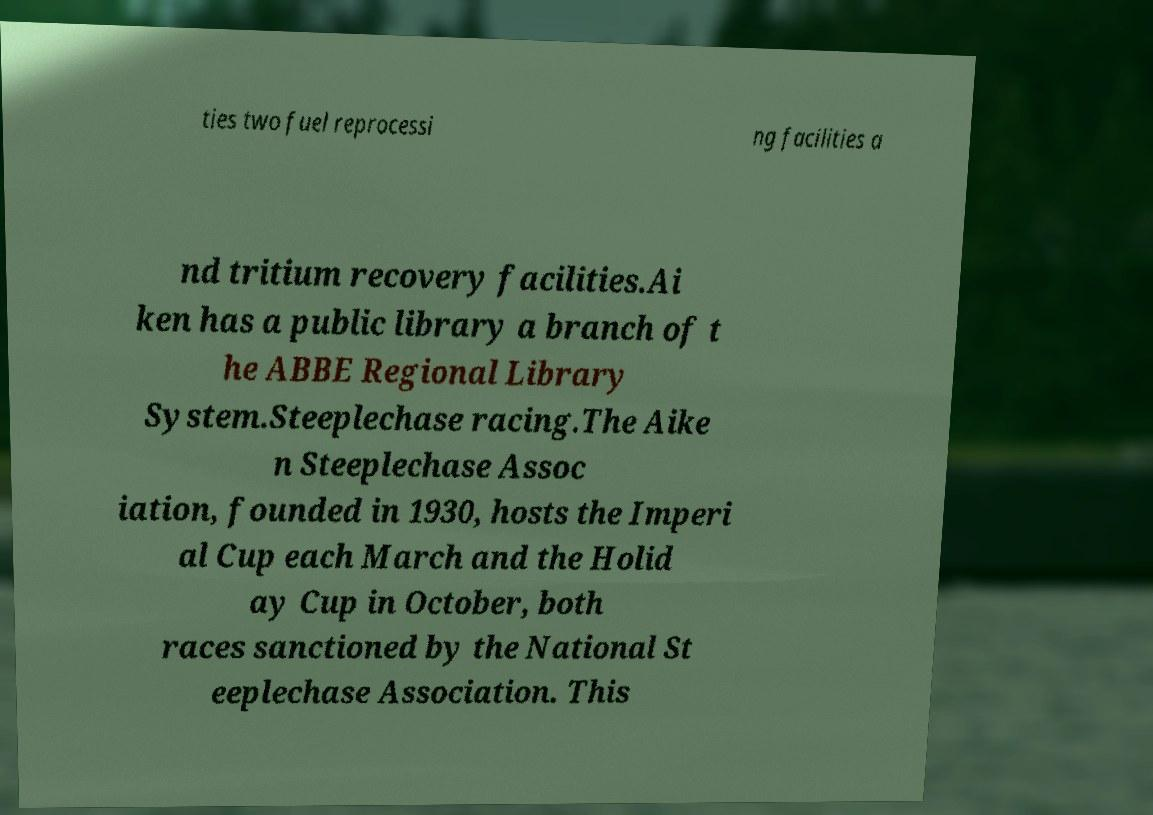For documentation purposes, I need the text within this image transcribed. Could you provide that? ties two fuel reprocessi ng facilities a nd tritium recovery facilities.Ai ken has a public library a branch of t he ABBE Regional Library System.Steeplechase racing.The Aike n Steeplechase Assoc iation, founded in 1930, hosts the Imperi al Cup each March and the Holid ay Cup in October, both races sanctioned by the National St eeplechase Association. This 